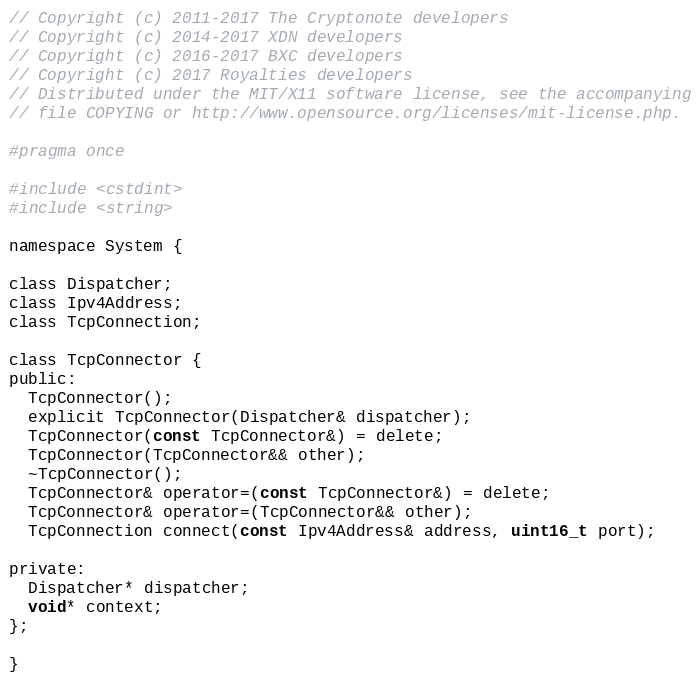Convert code to text. <code><loc_0><loc_0><loc_500><loc_500><_C_>// Copyright (c) 2011-2017 The Cryptonote developers
// Copyright (c) 2014-2017 XDN developers
// Copyright (c) 2016-2017 BXC developers
// Copyright (c) 2017 Royalties developers
// Distributed under the MIT/X11 software license, see the accompanying
// file COPYING or http://www.opensource.org/licenses/mit-license.php.

#pragma once

#include <cstdint>
#include <string>

namespace System {

class Dispatcher;
class Ipv4Address;
class TcpConnection;

class TcpConnector {
public:
  TcpConnector();
  explicit TcpConnector(Dispatcher& dispatcher);
  TcpConnector(const TcpConnector&) = delete;
  TcpConnector(TcpConnector&& other);
  ~TcpConnector();
  TcpConnector& operator=(const TcpConnector&) = delete;
  TcpConnector& operator=(TcpConnector&& other);
  TcpConnection connect(const Ipv4Address& address, uint16_t port);

private:
  Dispatcher* dispatcher;
  void* context;
};

}
</code> 